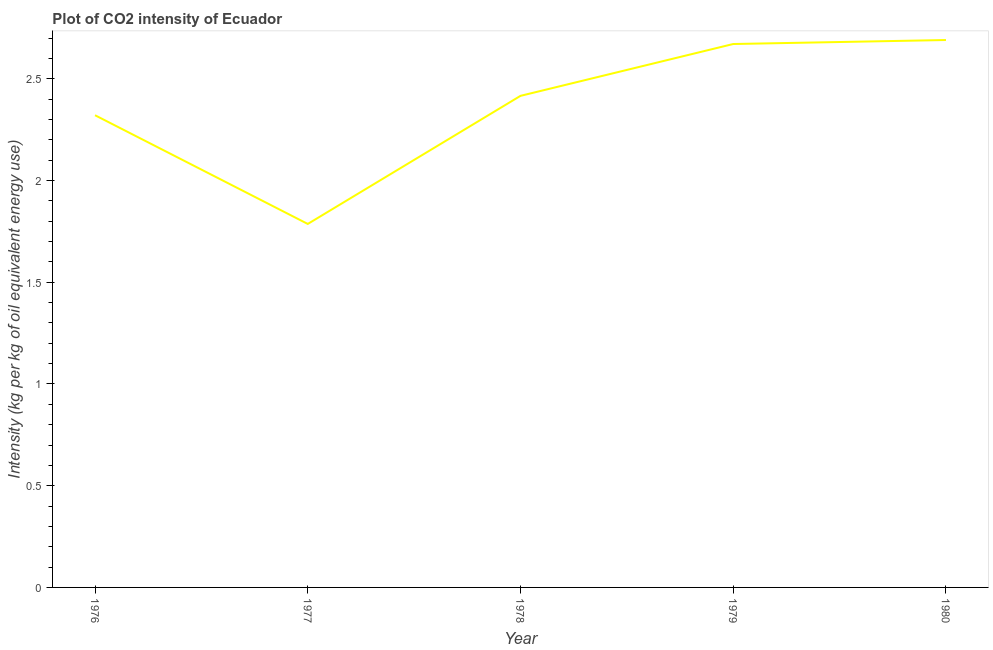What is the co2 intensity in 1980?
Provide a short and direct response. 2.69. Across all years, what is the maximum co2 intensity?
Offer a very short reply. 2.69. Across all years, what is the minimum co2 intensity?
Give a very brief answer. 1.79. In which year was the co2 intensity minimum?
Your response must be concise. 1977. What is the sum of the co2 intensity?
Make the answer very short. 11.89. What is the difference between the co2 intensity in 1977 and 1979?
Provide a short and direct response. -0.88. What is the average co2 intensity per year?
Make the answer very short. 2.38. What is the median co2 intensity?
Your response must be concise. 2.42. In how many years, is the co2 intensity greater than 0.6 kg?
Your answer should be very brief. 5. What is the ratio of the co2 intensity in 1978 to that in 1980?
Provide a succinct answer. 0.9. Is the co2 intensity in 1976 less than that in 1980?
Keep it short and to the point. Yes. Is the difference between the co2 intensity in 1977 and 1979 greater than the difference between any two years?
Make the answer very short. No. What is the difference between the highest and the second highest co2 intensity?
Keep it short and to the point. 0.02. Is the sum of the co2 intensity in 1977 and 1980 greater than the maximum co2 intensity across all years?
Your answer should be very brief. Yes. What is the difference between the highest and the lowest co2 intensity?
Your answer should be very brief. 0.9. In how many years, is the co2 intensity greater than the average co2 intensity taken over all years?
Your answer should be very brief. 3. Does the co2 intensity monotonically increase over the years?
Offer a terse response. No. How many years are there in the graph?
Provide a succinct answer. 5. What is the difference between two consecutive major ticks on the Y-axis?
Make the answer very short. 0.5. Does the graph contain any zero values?
Your answer should be compact. No. What is the title of the graph?
Ensure brevity in your answer.  Plot of CO2 intensity of Ecuador. What is the label or title of the Y-axis?
Give a very brief answer. Intensity (kg per kg of oil equivalent energy use). What is the Intensity (kg per kg of oil equivalent energy use) in 1976?
Keep it short and to the point. 2.32. What is the Intensity (kg per kg of oil equivalent energy use) in 1977?
Your response must be concise. 1.79. What is the Intensity (kg per kg of oil equivalent energy use) in 1978?
Give a very brief answer. 2.42. What is the Intensity (kg per kg of oil equivalent energy use) of 1979?
Provide a short and direct response. 2.67. What is the Intensity (kg per kg of oil equivalent energy use) of 1980?
Keep it short and to the point. 2.69. What is the difference between the Intensity (kg per kg of oil equivalent energy use) in 1976 and 1977?
Your response must be concise. 0.53. What is the difference between the Intensity (kg per kg of oil equivalent energy use) in 1976 and 1978?
Ensure brevity in your answer.  -0.1. What is the difference between the Intensity (kg per kg of oil equivalent energy use) in 1976 and 1979?
Offer a very short reply. -0.35. What is the difference between the Intensity (kg per kg of oil equivalent energy use) in 1976 and 1980?
Offer a terse response. -0.37. What is the difference between the Intensity (kg per kg of oil equivalent energy use) in 1977 and 1978?
Ensure brevity in your answer.  -0.63. What is the difference between the Intensity (kg per kg of oil equivalent energy use) in 1977 and 1979?
Offer a very short reply. -0.88. What is the difference between the Intensity (kg per kg of oil equivalent energy use) in 1977 and 1980?
Provide a succinct answer. -0.9. What is the difference between the Intensity (kg per kg of oil equivalent energy use) in 1978 and 1979?
Provide a succinct answer. -0.25. What is the difference between the Intensity (kg per kg of oil equivalent energy use) in 1978 and 1980?
Your answer should be very brief. -0.27. What is the difference between the Intensity (kg per kg of oil equivalent energy use) in 1979 and 1980?
Your answer should be very brief. -0.02. What is the ratio of the Intensity (kg per kg of oil equivalent energy use) in 1976 to that in 1977?
Ensure brevity in your answer.  1.3. What is the ratio of the Intensity (kg per kg of oil equivalent energy use) in 1976 to that in 1978?
Provide a succinct answer. 0.96. What is the ratio of the Intensity (kg per kg of oil equivalent energy use) in 1976 to that in 1979?
Your answer should be compact. 0.87. What is the ratio of the Intensity (kg per kg of oil equivalent energy use) in 1976 to that in 1980?
Provide a succinct answer. 0.86. What is the ratio of the Intensity (kg per kg of oil equivalent energy use) in 1977 to that in 1978?
Keep it short and to the point. 0.74. What is the ratio of the Intensity (kg per kg of oil equivalent energy use) in 1977 to that in 1979?
Keep it short and to the point. 0.67. What is the ratio of the Intensity (kg per kg of oil equivalent energy use) in 1977 to that in 1980?
Keep it short and to the point. 0.66. What is the ratio of the Intensity (kg per kg of oil equivalent energy use) in 1978 to that in 1979?
Your response must be concise. 0.91. What is the ratio of the Intensity (kg per kg of oil equivalent energy use) in 1978 to that in 1980?
Offer a very short reply. 0.9. What is the ratio of the Intensity (kg per kg of oil equivalent energy use) in 1979 to that in 1980?
Give a very brief answer. 0.99. 